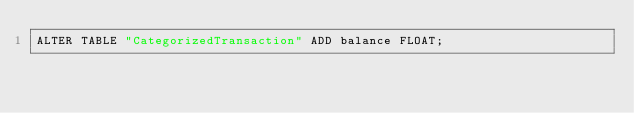Convert code to text. <code><loc_0><loc_0><loc_500><loc_500><_SQL_>ALTER TABLE "CategorizedTransaction" ADD balance FLOAT;</code> 